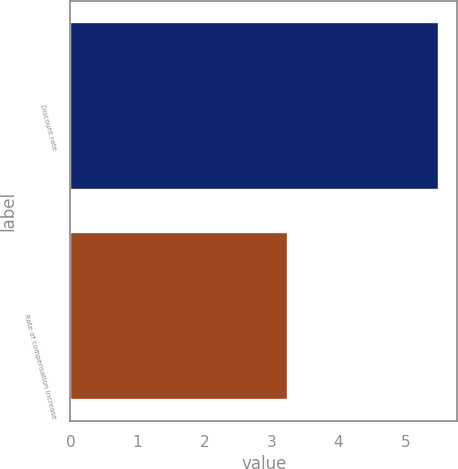Convert chart to OTSL. <chart><loc_0><loc_0><loc_500><loc_500><bar_chart><fcel>Discount rate<fcel>Rate of compensation increase<nl><fcel>5.5<fcel>3.25<nl></chart> 